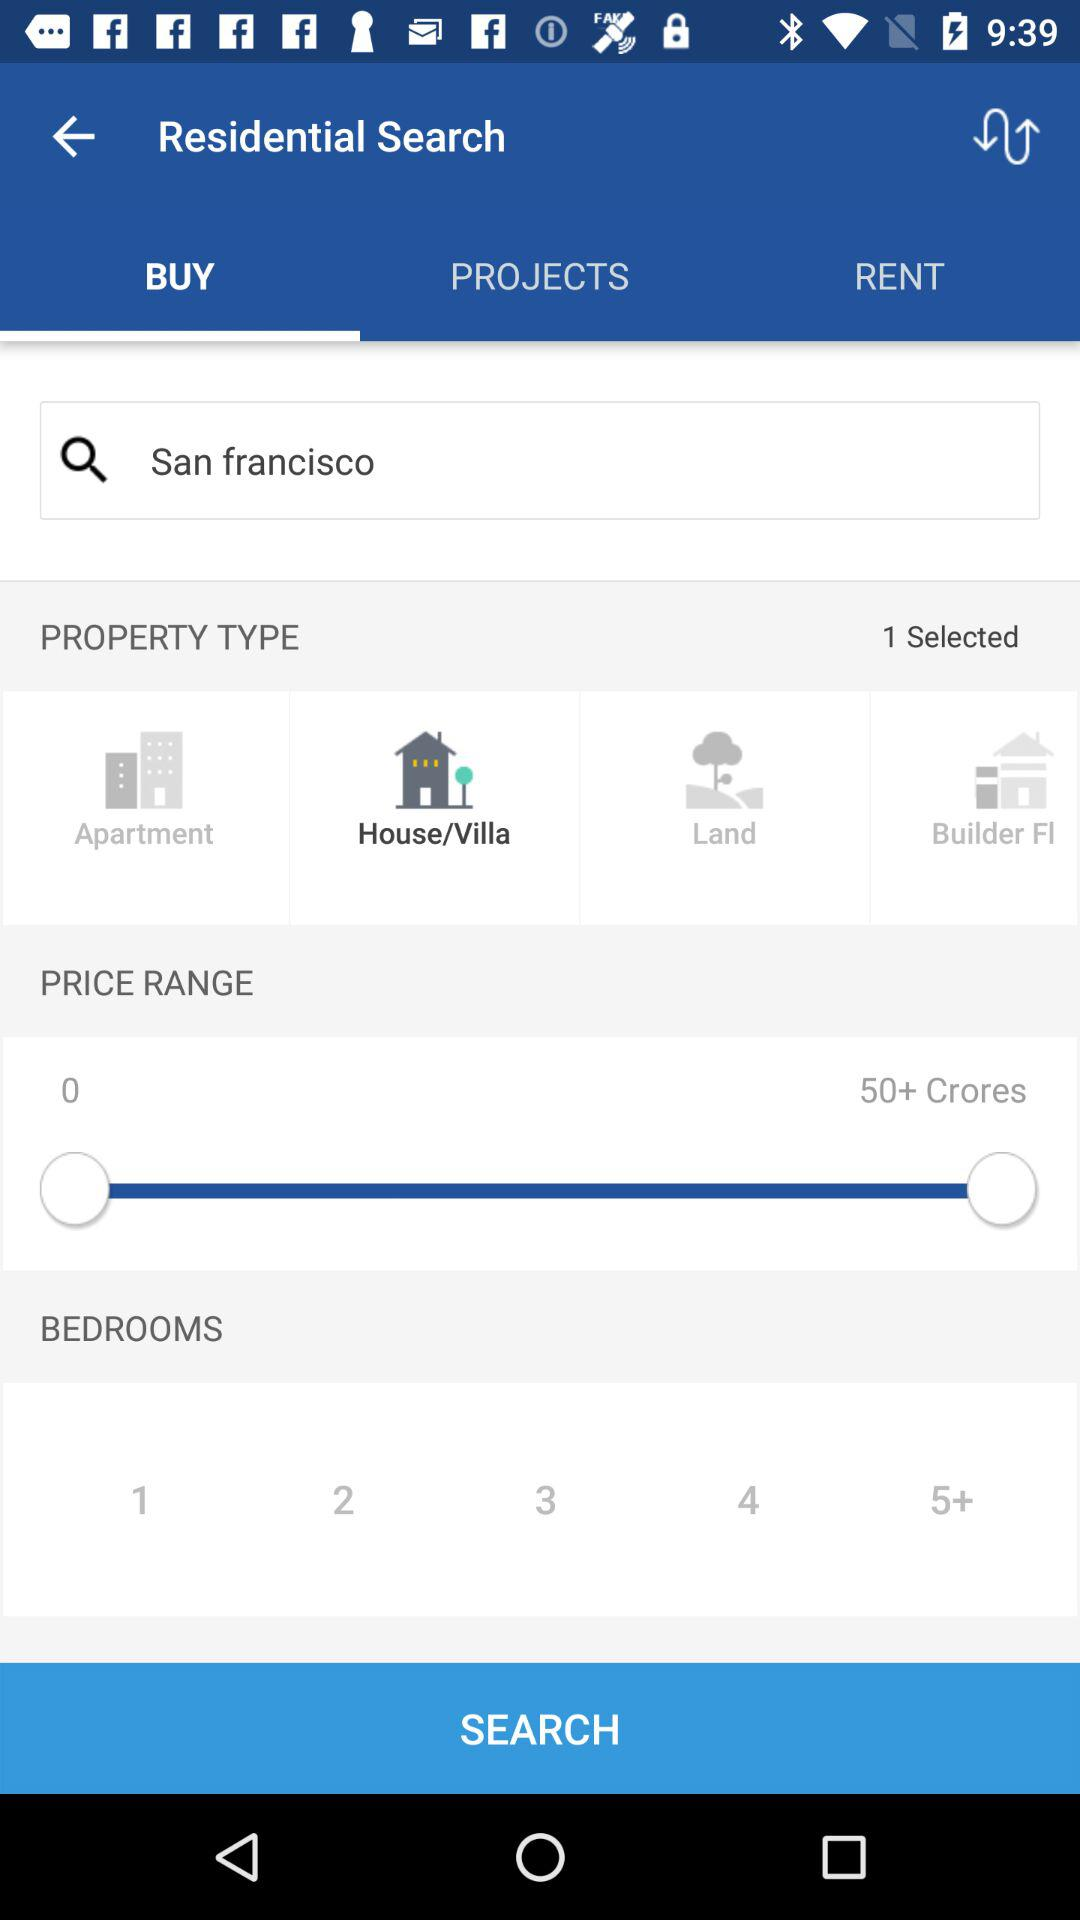What is the maximum limit of the price range? The maximum limit is 50+ crores. 